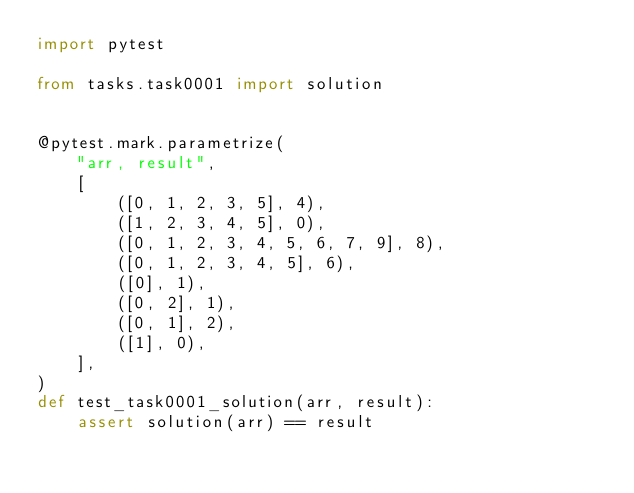Convert code to text. <code><loc_0><loc_0><loc_500><loc_500><_Python_>import pytest

from tasks.task0001 import solution


@pytest.mark.parametrize(
    "arr, result",
    [
        ([0, 1, 2, 3, 5], 4),
        ([1, 2, 3, 4, 5], 0),
        ([0, 1, 2, 3, 4, 5, 6, 7, 9], 8),
        ([0, 1, 2, 3, 4, 5], 6),
        ([0], 1),
        ([0, 2], 1),
        ([0, 1], 2),
        ([1], 0),
    ],
)
def test_task0001_solution(arr, result):
    assert solution(arr) == result
</code> 